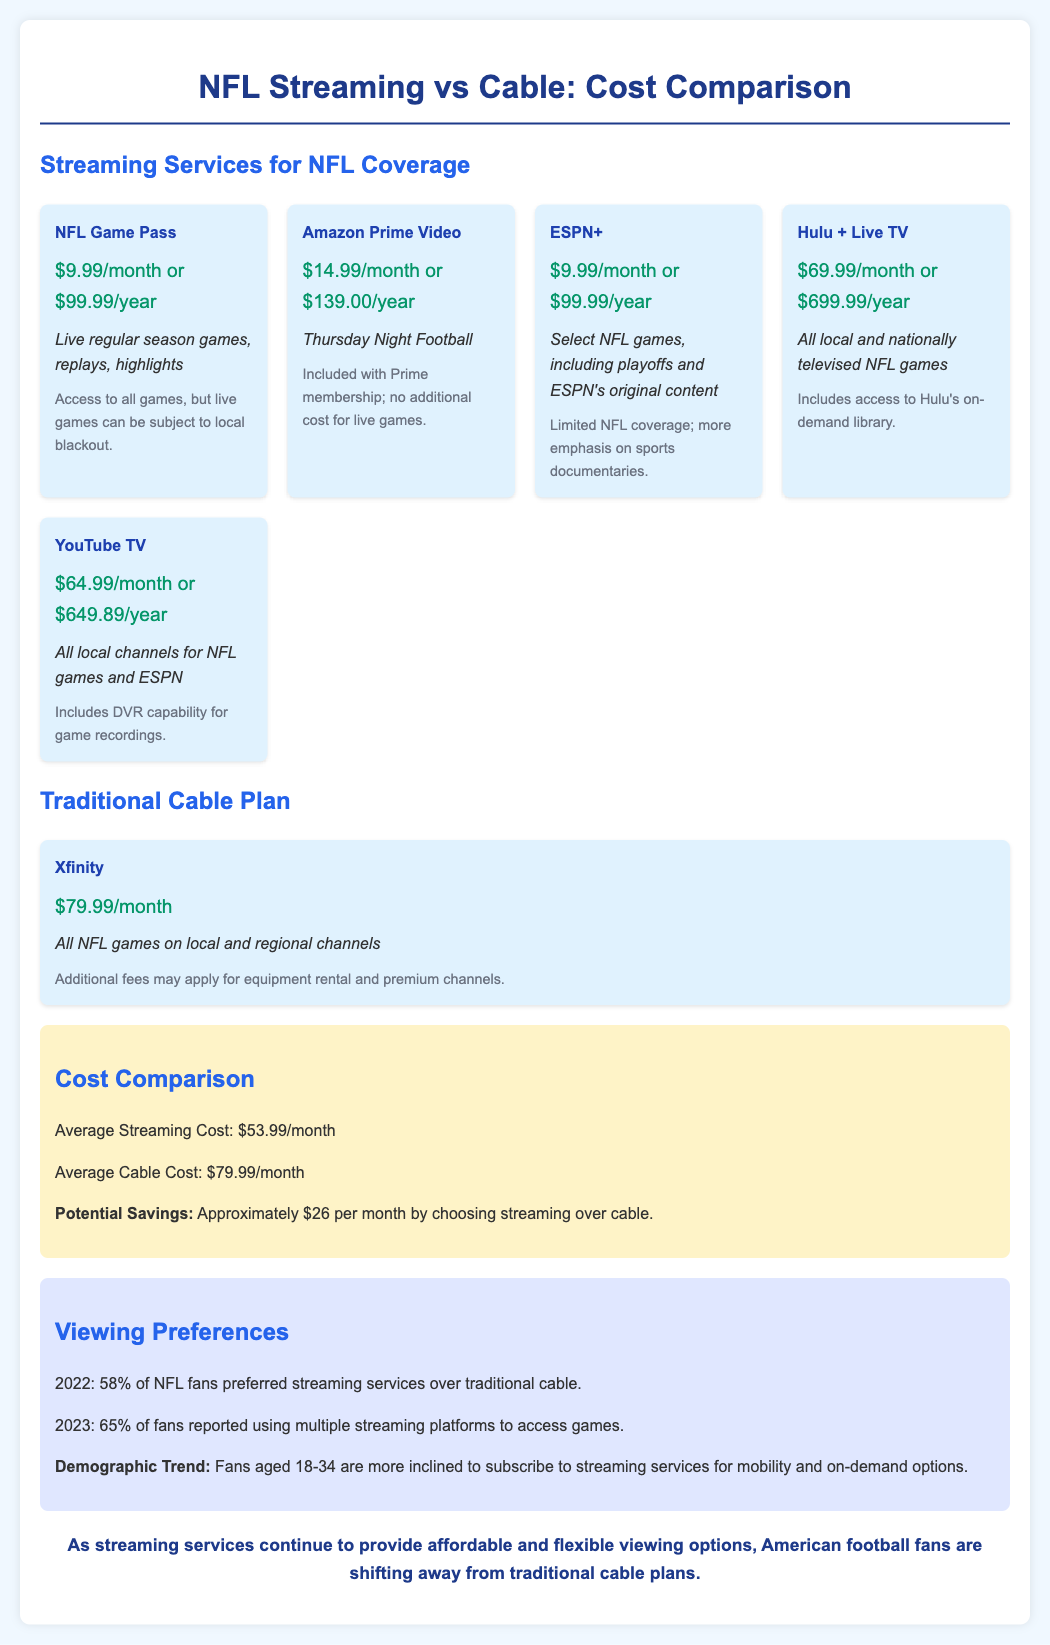What is the cost of NFL Game Pass? The cost for NFL Game Pass is listed as $9.99 per month or $99.99 per year.
Answer: $9.99/month or $99.99/year What percentage of NFL fans preferred streaming in 2022? The document states that in 2022, 58% of NFL fans preferred streaming services over traditional cable.
Answer: 58% What is the average monthly cost of streaming services? The document provides the average streaming cost as $53.99 per month.
Answer: $53.99/month What is the coverage of YouTube TV? YouTube TV covers all local channels for NFL games and ESPN.
Answer: All local channels for NFL games and ESPN What was the demographic trend for fans aged 18-34? The document mentions that this demographic is more inclined to subscribe to streaming services for mobility and on-demand options.
Answer: Mobility and on-demand options What is the potential savings when choosing streaming over cable? The document states that the potential savings are approximately $26 per month by choosing streaming over cable.
Answer: Approximately $26 per month What is the cost of Hulu + Live TV? Hulu + Live TV is priced at $69.99 per month or $699.99 per year.
Answer: $69.99/month or $699.99/year How many years are covered by the annual subscription of ESPN+? The annual subscription of ESPN+ covers one year.
Answer: One year What is the coverage note for NFL Game Pass? The note states that access to all games is available, but live games can be subject to local blackout.
Answer: Live games can be subject to local blackout 